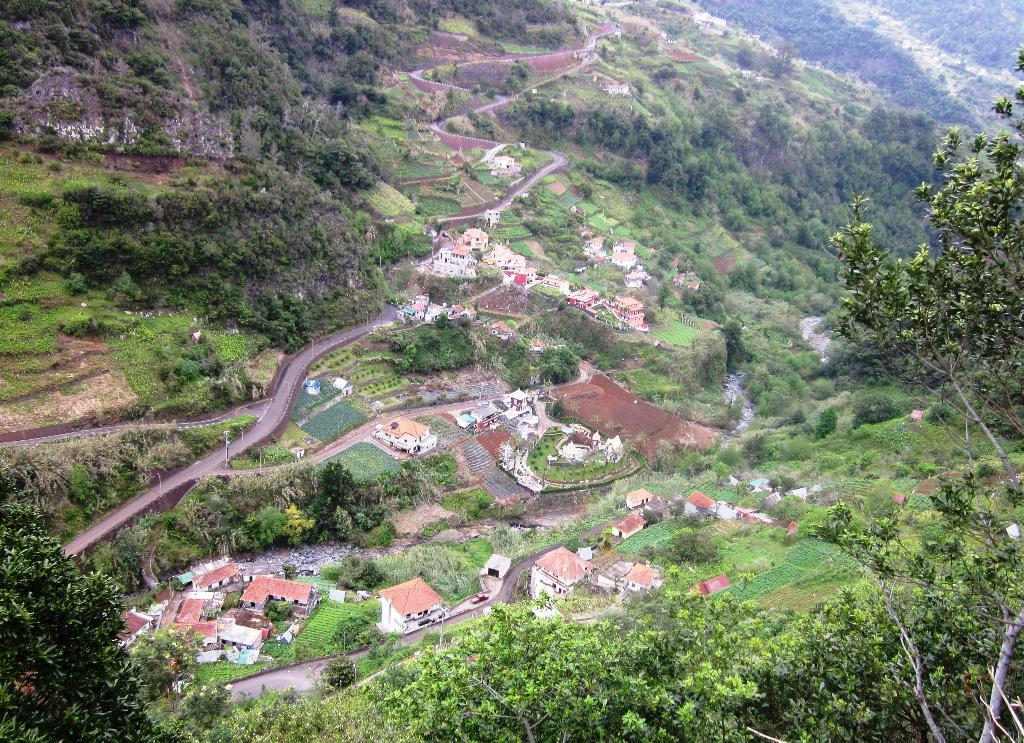What type of vegetation can be seen in the image? There are trees and grass in the image. What kind of landscape features are present in the image? There are hills in the image. Are there any man-made structures visible in the image? Yes, there are houses in the image. What other living organisms can be seen in the image? There are plants in the image. What direction is the face of the person in the image looking? There is no person present in the image, so there is no face to determine the direction it is looking. 